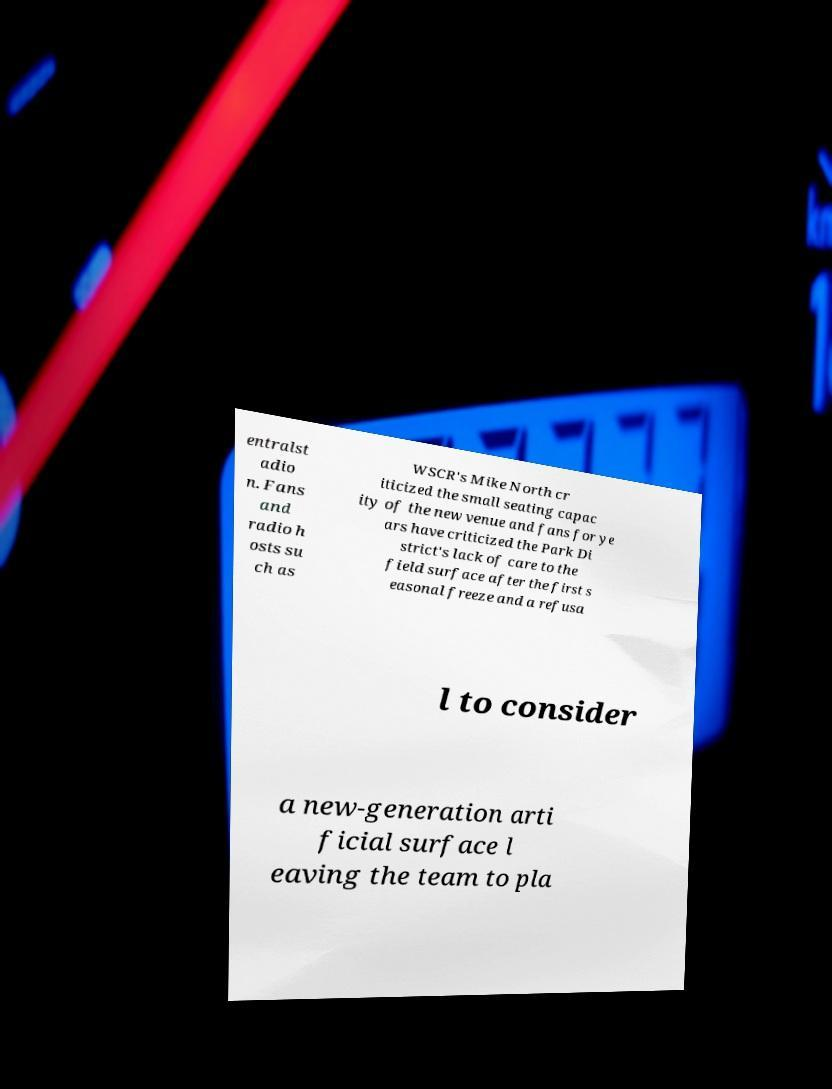Please read and relay the text visible in this image. What does it say? entralst adio n. Fans and radio h osts su ch as WSCR's Mike North cr iticized the small seating capac ity of the new venue and fans for ye ars have criticized the Park Di strict's lack of care to the field surface after the first s easonal freeze and a refusa l to consider a new-generation arti ficial surface l eaving the team to pla 